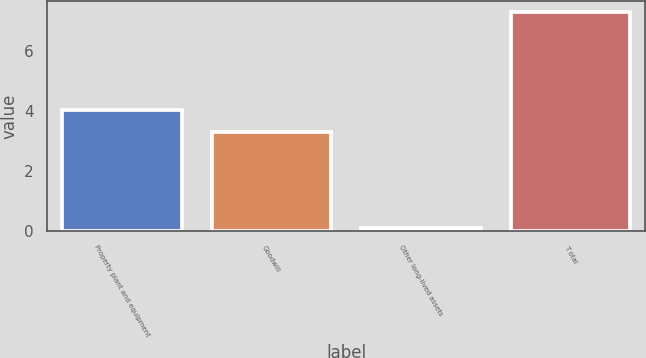<chart> <loc_0><loc_0><loc_500><loc_500><bar_chart><fcel>Property plant and equipment<fcel>Goodwill<fcel>Other long-lived assets<fcel>T otal<nl><fcel>4.02<fcel>3.3<fcel>0.1<fcel>7.3<nl></chart> 